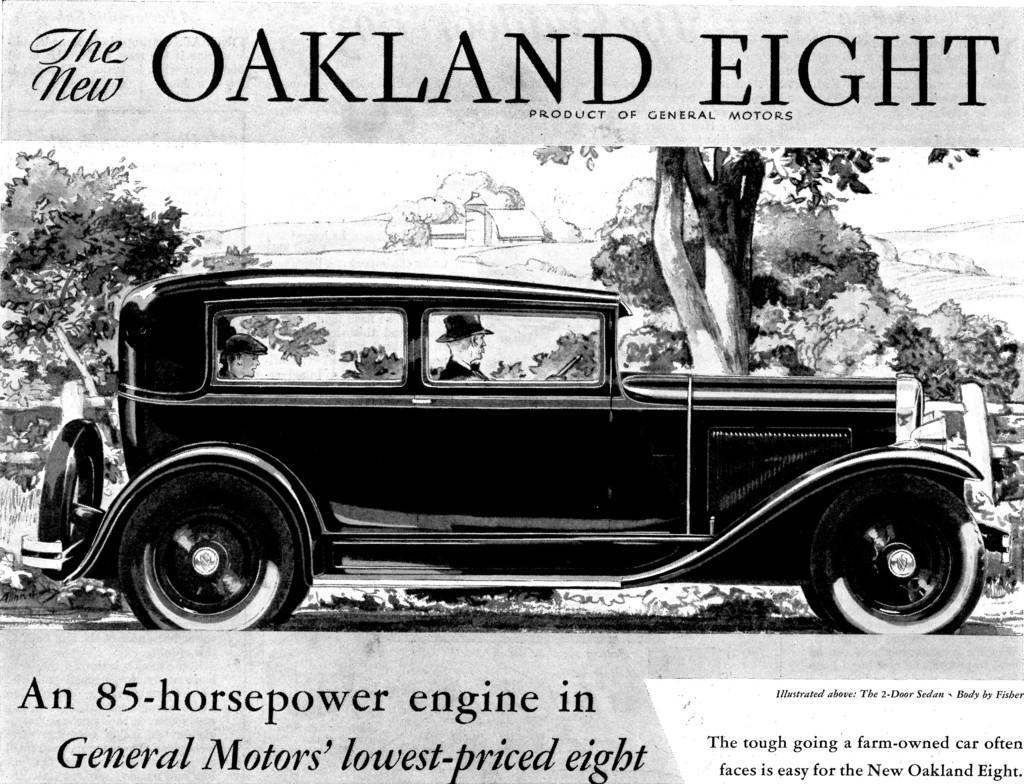Please provide a concise description of this image. There is a picture of a car in the middle of this image, and there are some trees in the background. There is some text at the top of this image, and at the bottom of this image as well. 